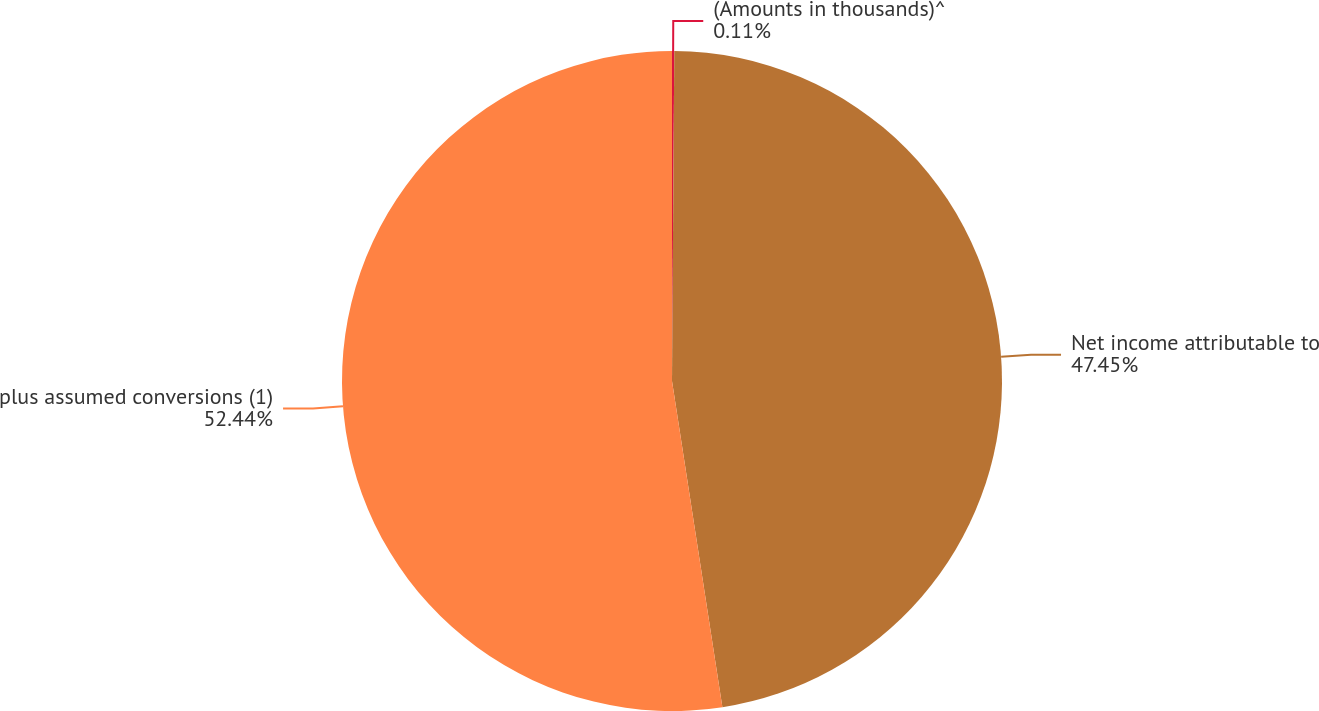<chart> <loc_0><loc_0><loc_500><loc_500><pie_chart><fcel>(Amounts in thousands)^<fcel>Net income attributable to<fcel>plus assumed conversions (1)<nl><fcel>0.11%<fcel>47.45%<fcel>52.44%<nl></chart> 